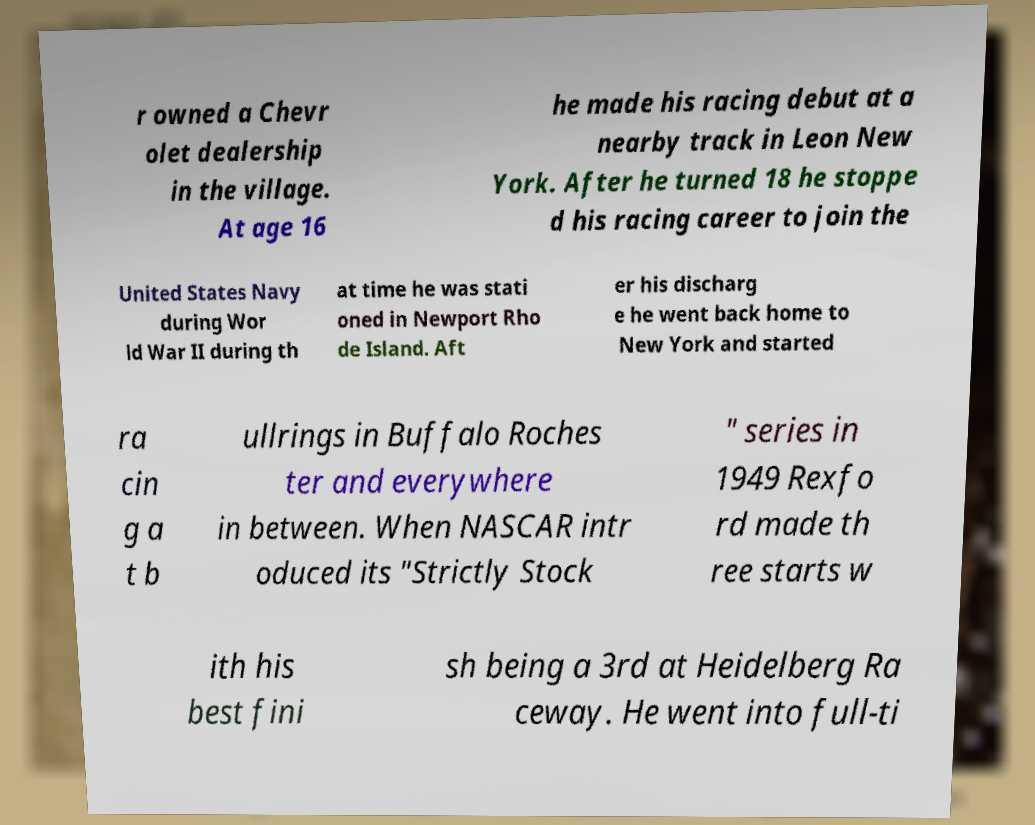For documentation purposes, I need the text within this image transcribed. Could you provide that? r owned a Chevr olet dealership in the village. At age 16 he made his racing debut at a nearby track in Leon New York. After he turned 18 he stoppe d his racing career to join the United States Navy during Wor ld War II during th at time he was stati oned in Newport Rho de Island. Aft er his discharg e he went back home to New York and started ra cin g a t b ullrings in Buffalo Roches ter and everywhere in between. When NASCAR intr oduced its "Strictly Stock " series in 1949 Rexfo rd made th ree starts w ith his best fini sh being a 3rd at Heidelberg Ra ceway. He went into full-ti 